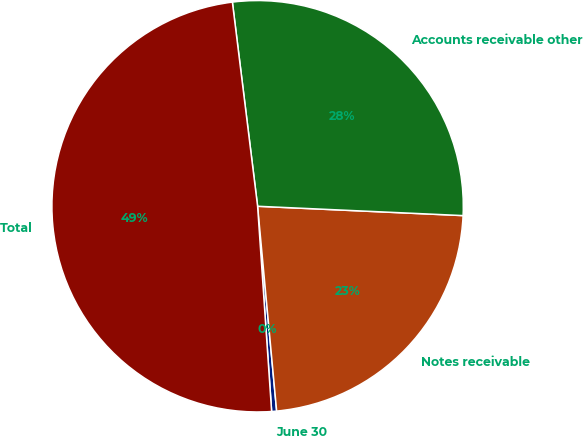<chart> <loc_0><loc_0><loc_500><loc_500><pie_chart><fcel>June 30<fcel>Notes receivable<fcel>Accounts receivable other<fcel>Total<nl><fcel>0.39%<fcel>22.8%<fcel>27.68%<fcel>49.13%<nl></chart> 